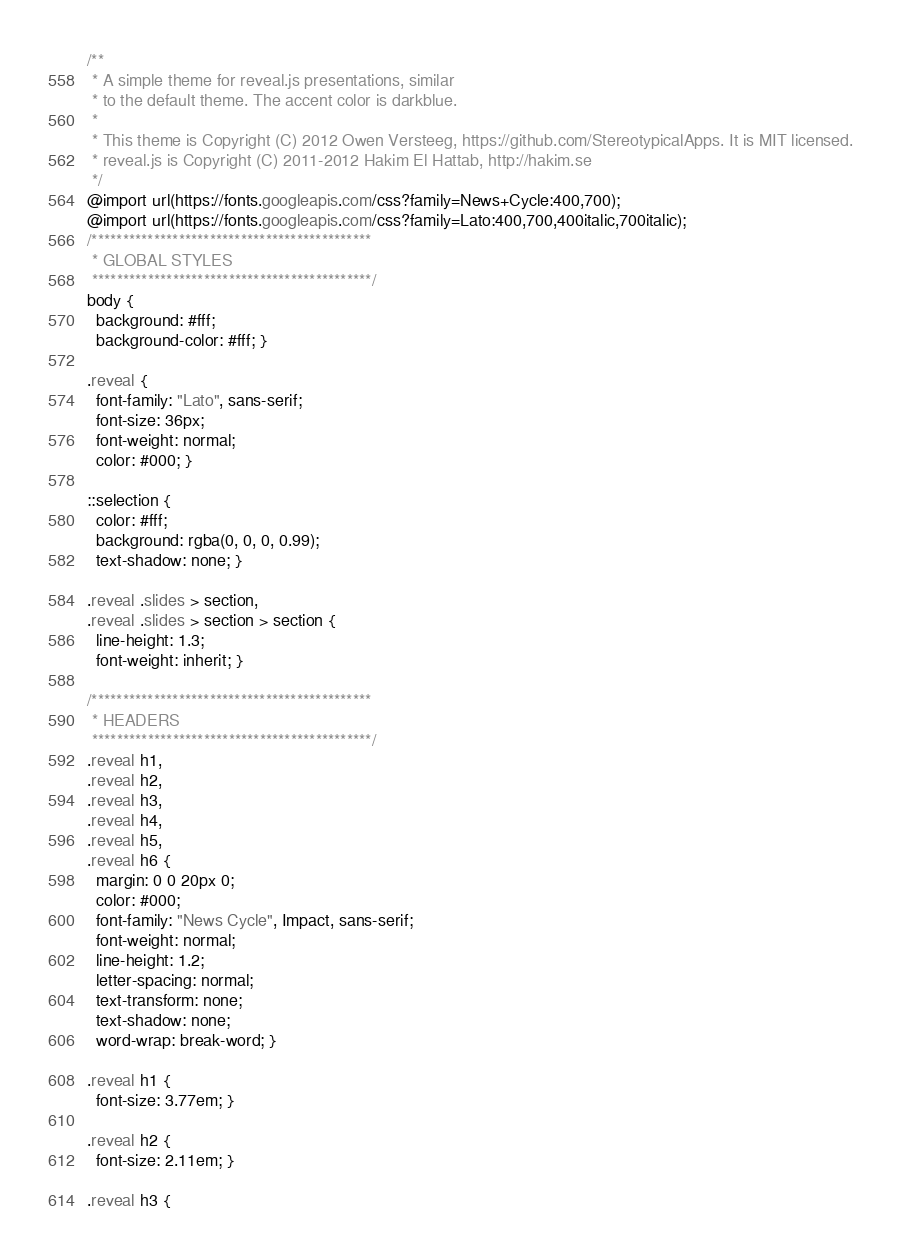<code> <loc_0><loc_0><loc_500><loc_500><_CSS_>/**
 * A simple theme for reveal.js presentations, similar
 * to the default theme. The accent color is darkblue.
 *
 * This theme is Copyright (C) 2012 Owen Versteeg, https://github.com/StereotypicalApps. It is MIT licensed.
 * reveal.js is Copyright (C) 2011-2012 Hakim El Hattab, http://hakim.se
 */
@import url(https://fonts.googleapis.com/css?family=News+Cycle:400,700);
@import url(https://fonts.googleapis.com/css?family=Lato:400,700,400italic,700italic);
/*********************************************
 * GLOBAL STYLES
 *********************************************/
body {
  background: #fff;
  background-color: #fff; }

.reveal {
  font-family: "Lato", sans-serif;
  font-size: 36px;
  font-weight: normal;
  color: #000; }

::selection {
  color: #fff;
  background: rgba(0, 0, 0, 0.99);
  text-shadow: none; }

.reveal .slides > section,
.reveal .slides > section > section {
  line-height: 1.3;
  font-weight: inherit; }

/*********************************************
 * HEADERS
 *********************************************/
.reveal h1,
.reveal h2,
.reveal h3,
.reveal h4,
.reveal h5,
.reveal h6 {
  margin: 0 0 20px 0;
  color: #000;
  font-family: "News Cycle", Impact, sans-serif;
  font-weight: normal;
  line-height: 1.2;
  letter-spacing: normal;
  text-transform: none;
  text-shadow: none;
  word-wrap: break-word; }

.reveal h1 {
  font-size: 3.77em; }

.reveal h2 {
  font-size: 2.11em; }

.reveal h3 {</code> 